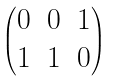<formula> <loc_0><loc_0><loc_500><loc_500>\begin{pmatrix} 0 & 0 & 1 \\ 1 & 1 & 0 \end{pmatrix}</formula> 